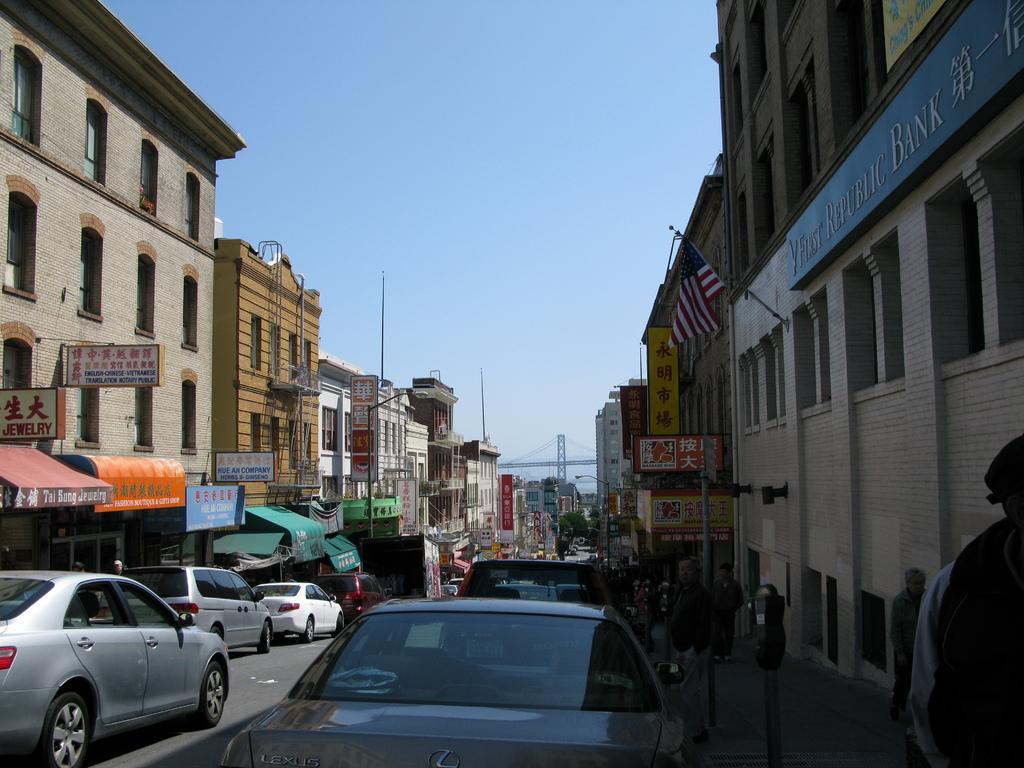Could you give a brief overview of what you see in this image? In this picture we can see a few vehicles on the road. There are some people, a machine, polish, a flag is visible on a building on the right side. We can see a few boards on the buildings. There are some trees and a tower is visible in the background. 